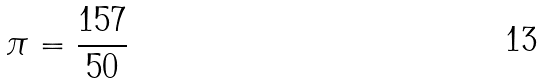Convert formula to latex. <formula><loc_0><loc_0><loc_500><loc_500>\pi = \frac { 1 5 7 } { 5 0 }</formula> 